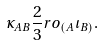<formula> <loc_0><loc_0><loc_500><loc_500>\kappa _ { A B } & \frac { 2 } { 3 } r o _ { ( A } \iota _ { B ) } .</formula> 